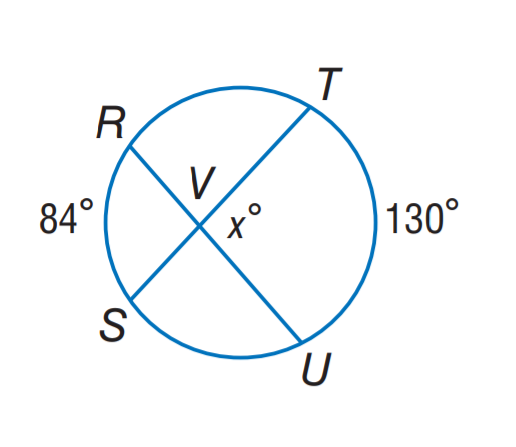Question: Find x.
Choices:
A. 84
B. 107
C. 130
D. 158
Answer with the letter. Answer: B 